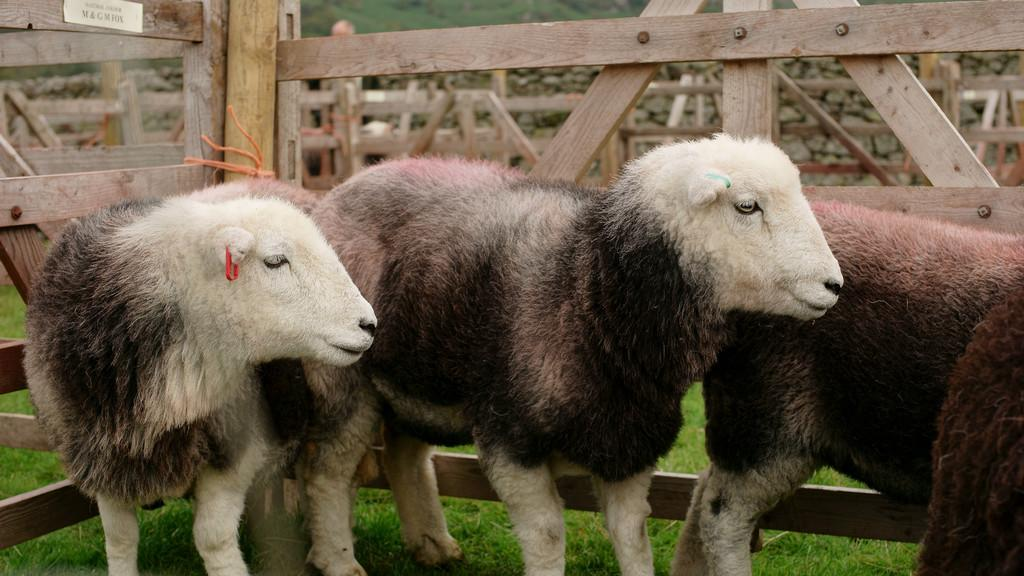What animals are present on the ground in the image? There are sheep on the ground in the image. What type of barrier can be seen in the image? There is a wooden fence in the image. What type of vegetation is visible in the image? There is grass visible in the image. Can you see any spots on the beetle in the image? There is no beetle present in the image, so it is not possible to see any spots on it. 